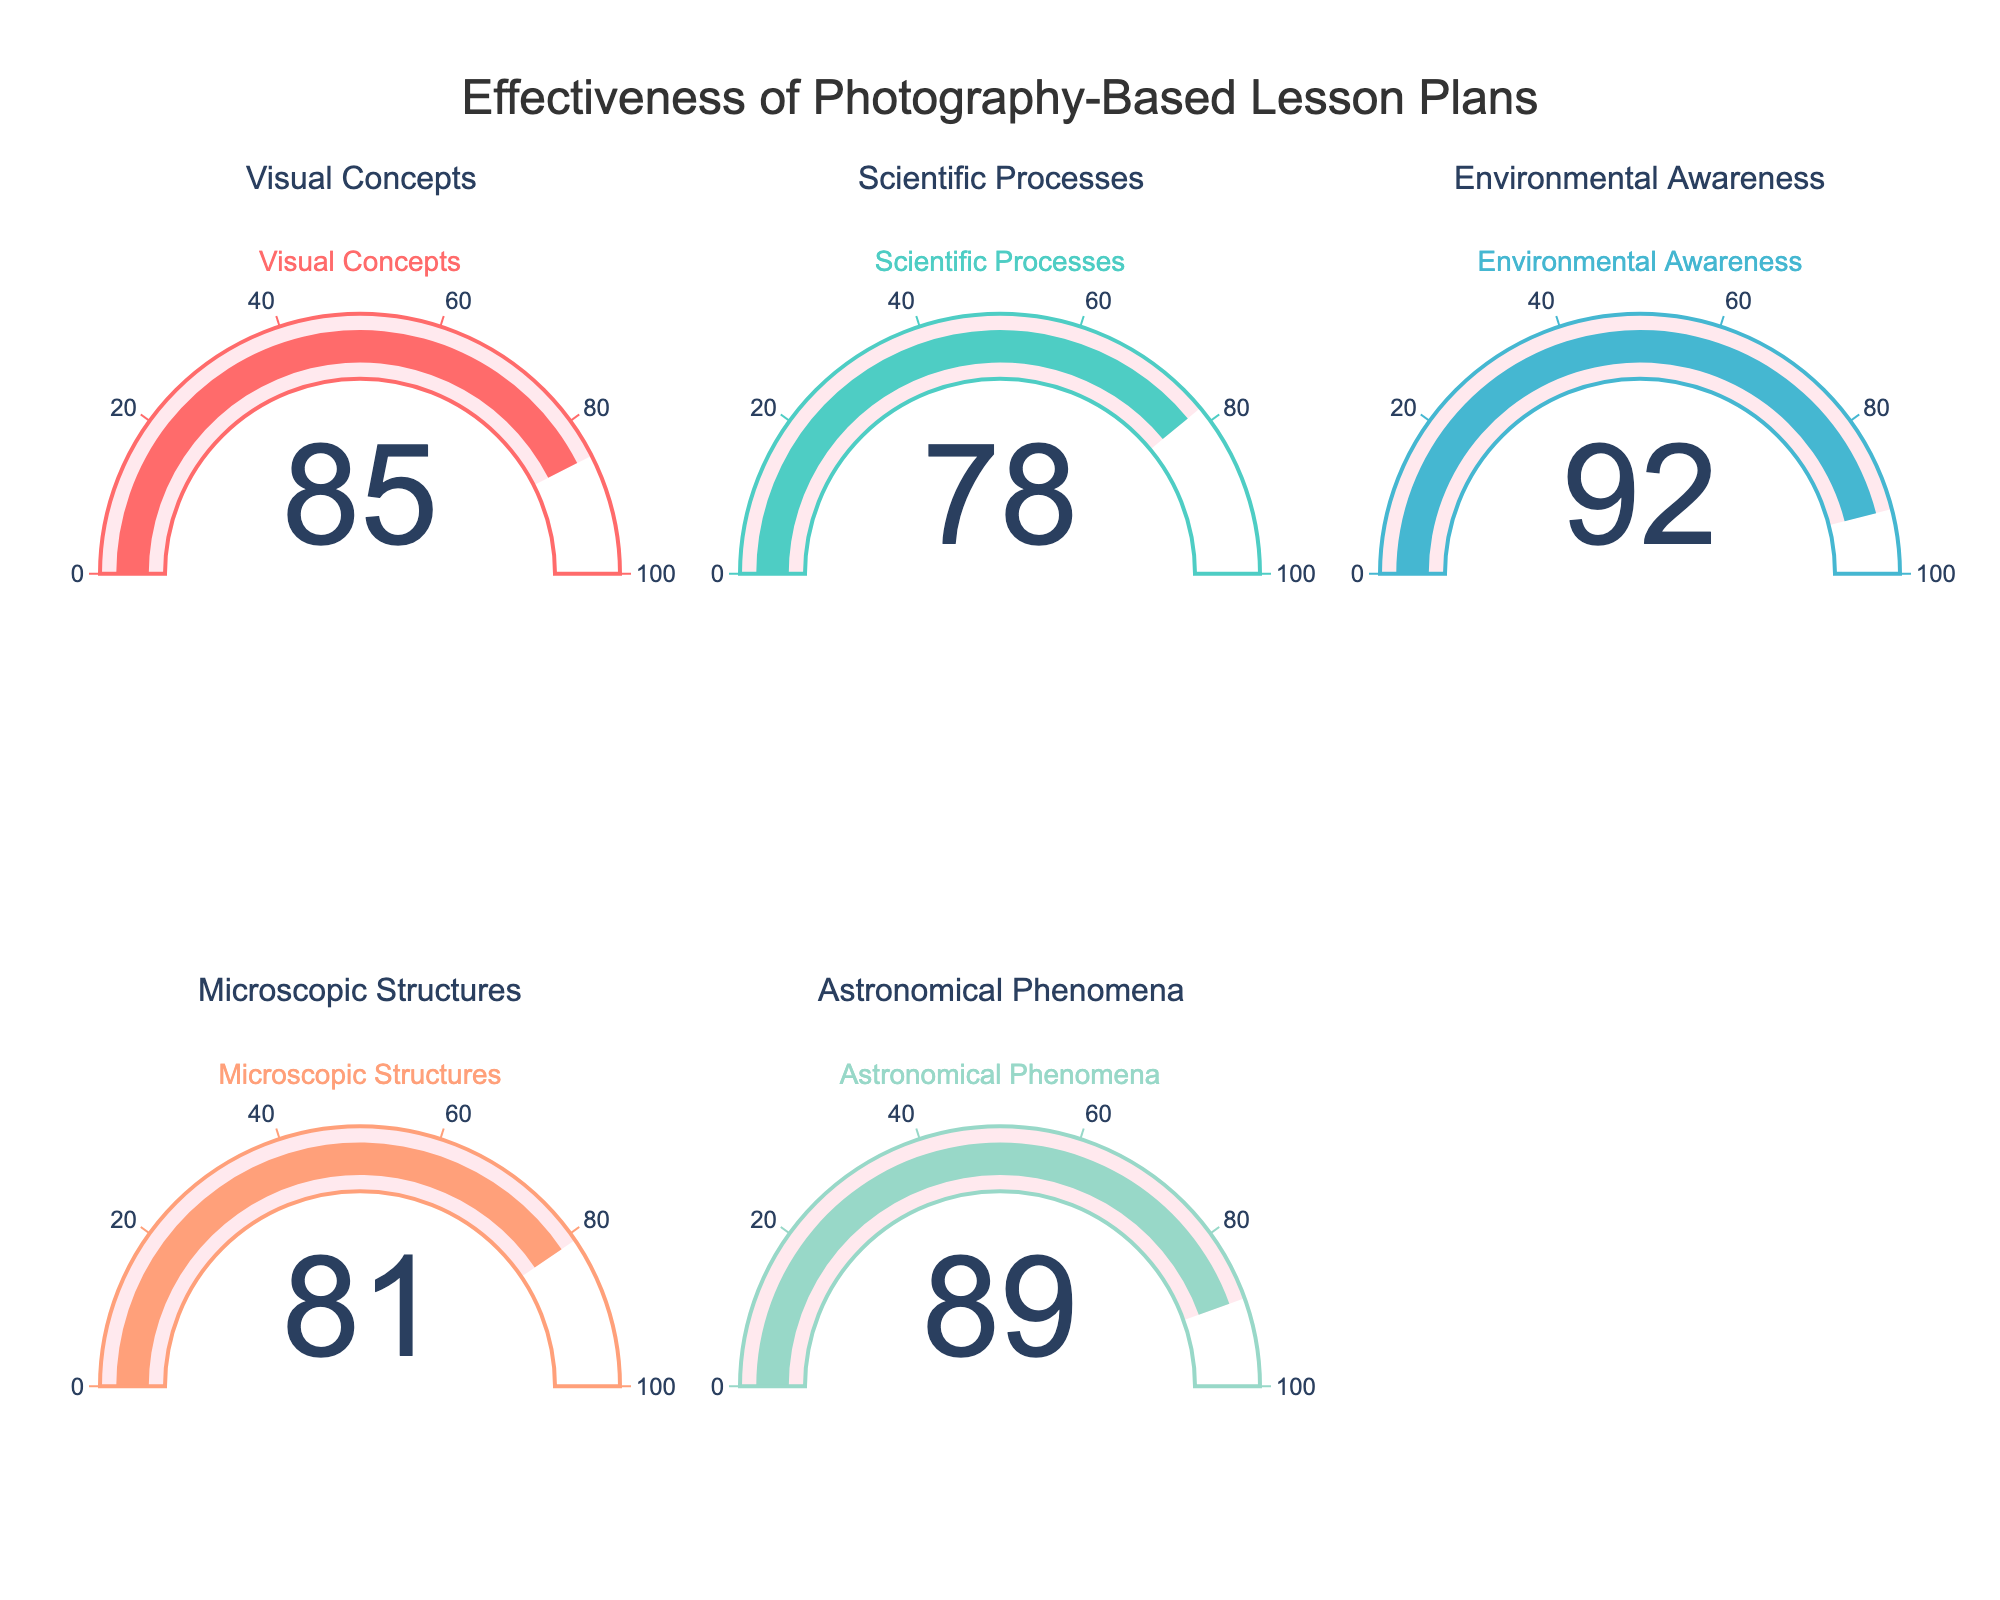Which subject has the highest retention rate? To find the highest retention rate, compare the values in all gauges. The highest value is 92 for Environmental Awareness.
Answer: Environmental Awareness What is the overall average retention rate across all subjects? Add all the retention rates (85 + 78 + 92 + 81 + 89) and then divide by the number of subjects (5). The sum is 425, so the average is 425/5 = 85.
Answer: 85 How much greater is the retention rate for Astronomical Phenomena than for Scientific Processes? Subtract the retention rate of Scientific Processes (78) from that of Astronomical Phenomena (89). The difference is 89 - 78 = 11.
Answer: 11 Among the subjects, which has the lowest retention rate? Compare the retention rates and find the smallest value. The lowest value is 78 for Scientific Processes.
Answer: Scientific Processes What is the median retention rate of the subjects in the figure? To find the median, order the retention rates: [78, 81, 85, 89, 92]. The middle value in this ordered list is 85.
Answer: 85 What subjects have a retention rate higher than the average? The average retention rate is 85. The subjects with rates higher than 85 are Environmental Awareness (92) and Astronomical Phenomena (89).
Answer: Environmental Awareness, Astronomical Phenomena What is the range of retention rates across different subjects? Subtract the smallest retention rate from the highest retention rate. The range is 92 (highest) - 78 (lowest) = 14.
Answer: 14 How much higher is the retention rate for Environmental Awareness compared to Microscopic Structures? Subtract the retention rate of Microscopic Structures (81) from that of Environmental Awareness (92). The difference is 92 - 81 = 11.
Answer: 11 What color is used for the gauge of Visual Concepts? The gauge for Visual Concepts is represented with a color that looks like red.
Answer: red What is the difference in retention rates between the highest and lowest rated subjects? Subtract the retention rate of the lowest rated subject (Scientific Processes, 78) from that of the highest rated subject (Environmental Awareness, 92). The difference is 92 - 78 = 14.
Answer: 14 